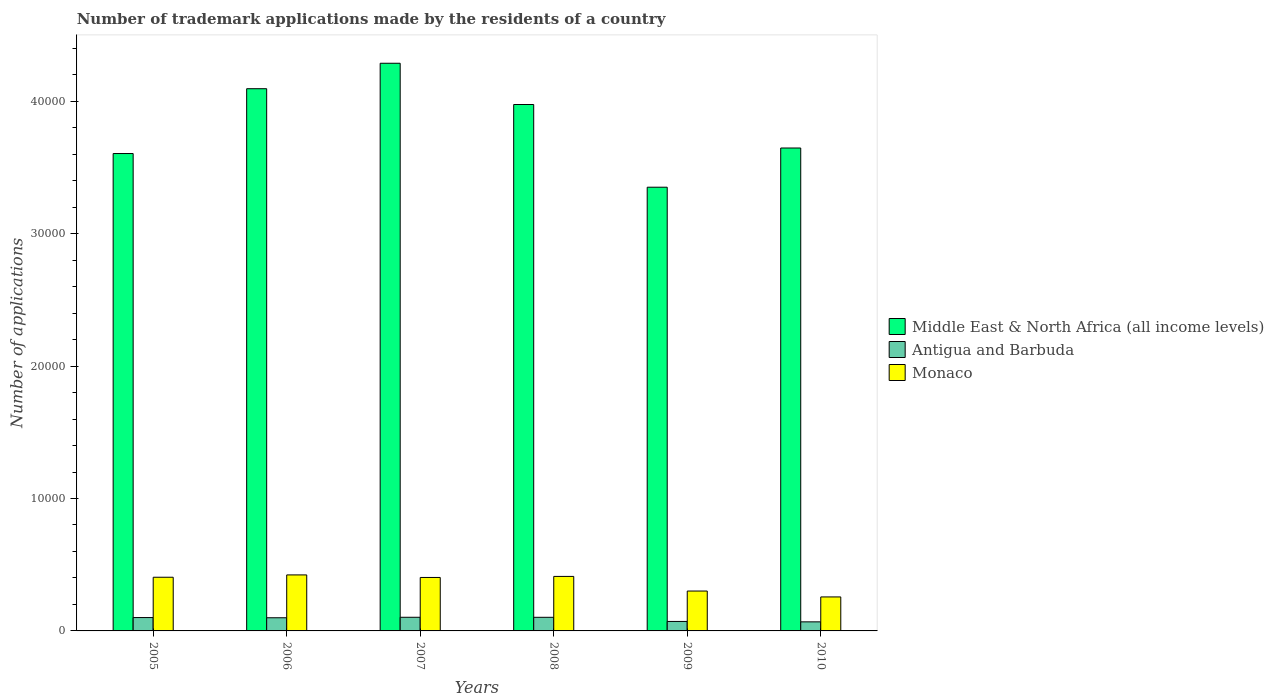Are the number of bars per tick equal to the number of legend labels?
Provide a succinct answer. Yes. How many bars are there on the 5th tick from the right?
Give a very brief answer. 3. What is the label of the 2nd group of bars from the left?
Offer a very short reply. 2006. In how many cases, is the number of bars for a given year not equal to the number of legend labels?
Your response must be concise. 0. What is the number of trademark applications made by the residents in Antigua and Barbuda in 2007?
Offer a very short reply. 1031. Across all years, what is the maximum number of trademark applications made by the residents in Monaco?
Give a very brief answer. 4229. Across all years, what is the minimum number of trademark applications made by the residents in Middle East & North Africa (all income levels)?
Provide a short and direct response. 3.35e+04. In which year was the number of trademark applications made by the residents in Middle East & North Africa (all income levels) minimum?
Your answer should be very brief. 2009. What is the total number of trademark applications made by the residents in Middle East & North Africa (all income levels) in the graph?
Your answer should be compact. 2.30e+05. What is the difference between the number of trademark applications made by the residents in Monaco in 2006 and that in 2007?
Offer a very short reply. 192. What is the difference between the number of trademark applications made by the residents in Antigua and Barbuda in 2009 and the number of trademark applications made by the residents in Middle East & North Africa (all income levels) in 2006?
Make the answer very short. -4.02e+04. What is the average number of trademark applications made by the residents in Middle East & North Africa (all income levels) per year?
Offer a very short reply. 3.83e+04. In the year 2005, what is the difference between the number of trademark applications made by the residents in Middle East & North Africa (all income levels) and number of trademark applications made by the residents in Monaco?
Your response must be concise. 3.20e+04. In how many years, is the number of trademark applications made by the residents in Antigua and Barbuda greater than 8000?
Make the answer very short. 0. What is the ratio of the number of trademark applications made by the residents in Monaco in 2005 to that in 2007?
Offer a very short reply. 1. Is the difference between the number of trademark applications made by the residents in Middle East & North Africa (all income levels) in 2008 and 2009 greater than the difference between the number of trademark applications made by the residents in Monaco in 2008 and 2009?
Ensure brevity in your answer.  Yes. What is the difference between the highest and the lowest number of trademark applications made by the residents in Antigua and Barbuda?
Your response must be concise. 346. In how many years, is the number of trademark applications made by the residents in Monaco greater than the average number of trademark applications made by the residents in Monaco taken over all years?
Provide a succinct answer. 4. Is the sum of the number of trademark applications made by the residents in Monaco in 2005 and 2009 greater than the maximum number of trademark applications made by the residents in Antigua and Barbuda across all years?
Ensure brevity in your answer.  Yes. What does the 3rd bar from the left in 2008 represents?
Your answer should be very brief. Monaco. What does the 3rd bar from the right in 2008 represents?
Make the answer very short. Middle East & North Africa (all income levels). Is it the case that in every year, the sum of the number of trademark applications made by the residents in Antigua and Barbuda and number of trademark applications made by the residents in Middle East & North Africa (all income levels) is greater than the number of trademark applications made by the residents in Monaco?
Offer a very short reply. Yes. How many bars are there?
Provide a succinct answer. 18. Are the values on the major ticks of Y-axis written in scientific E-notation?
Make the answer very short. No. Does the graph contain any zero values?
Keep it short and to the point. No. What is the title of the graph?
Make the answer very short. Number of trademark applications made by the residents of a country. What is the label or title of the X-axis?
Your response must be concise. Years. What is the label or title of the Y-axis?
Keep it short and to the point. Number of applications. What is the Number of applications of Middle East & North Africa (all income levels) in 2005?
Ensure brevity in your answer.  3.60e+04. What is the Number of applications in Antigua and Barbuda in 2005?
Make the answer very short. 1009. What is the Number of applications of Monaco in 2005?
Your response must be concise. 4053. What is the Number of applications of Middle East & North Africa (all income levels) in 2006?
Offer a very short reply. 4.09e+04. What is the Number of applications in Antigua and Barbuda in 2006?
Your answer should be very brief. 994. What is the Number of applications in Monaco in 2006?
Your answer should be very brief. 4229. What is the Number of applications in Middle East & North Africa (all income levels) in 2007?
Offer a terse response. 4.29e+04. What is the Number of applications in Antigua and Barbuda in 2007?
Keep it short and to the point. 1031. What is the Number of applications in Monaco in 2007?
Give a very brief answer. 4037. What is the Number of applications of Middle East & North Africa (all income levels) in 2008?
Provide a succinct answer. 3.98e+04. What is the Number of applications of Antigua and Barbuda in 2008?
Your answer should be compact. 1028. What is the Number of applications in Monaco in 2008?
Your response must be concise. 4116. What is the Number of applications in Middle East & North Africa (all income levels) in 2009?
Ensure brevity in your answer.  3.35e+04. What is the Number of applications of Antigua and Barbuda in 2009?
Provide a succinct answer. 716. What is the Number of applications in Monaco in 2009?
Your answer should be very brief. 3011. What is the Number of applications in Middle East & North Africa (all income levels) in 2010?
Provide a short and direct response. 3.65e+04. What is the Number of applications in Antigua and Barbuda in 2010?
Offer a very short reply. 685. What is the Number of applications in Monaco in 2010?
Your answer should be very brief. 2567. Across all years, what is the maximum Number of applications of Middle East & North Africa (all income levels)?
Your answer should be compact. 4.29e+04. Across all years, what is the maximum Number of applications of Antigua and Barbuda?
Your response must be concise. 1031. Across all years, what is the maximum Number of applications in Monaco?
Offer a terse response. 4229. Across all years, what is the minimum Number of applications of Middle East & North Africa (all income levels)?
Keep it short and to the point. 3.35e+04. Across all years, what is the minimum Number of applications in Antigua and Barbuda?
Your answer should be compact. 685. Across all years, what is the minimum Number of applications of Monaco?
Ensure brevity in your answer.  2567. What is the total Number of applications of Middle East & North Africa (all income levels) in the graph?
Provide a succinct answer. 2.30e+05. What is the total Number of applications of Antigua and Barbuda in the graph?
Provide a succinct answer. 5463. What is the total Number of applications of Monaco in the graph?
Keep it short and to the point. 2.20e+04. What is the difference between the Number of applications of Middle East & North Africa (all income levels) in 2005 and that in 2006?
Your answer should be very brief. -4895. What is the difference between the Number of applications of Monaco in 2005 and that in 2006?
Provide a succinct answer. -176. What is the difference between the Number of applications of Middle East & North Africa (all income levels) in 2005 and that in 2007?
Your answer should be very brief. -6817. What is the difference between the Number of applications of Antigua and Barbuda in 2005 and that in 2007?
Your answer should be compact. -22. What is the difference between the Number of applications of Middle East & North Africa (all income levels) in 2005 and that in 2008?
Offer a terse response. -3702. What is the difference between the Number of applications in Monaco in 2005 and that in 2008?
Provide a short and direct response. -63. What is the difference between the Number of applications in Middle East & North Africa (all income levels) in 2005 and that in 2009?
Your answer should be very brief. 2543. What is the difference between the Number of applications of Antigua and Barbuda in 2005 and that in 2009?
Keep it short and to the point. 293. What is the difference between the Number of applications of Monaco in 2005 and that in 2009?
Make the answer very short. 1042. What is the difference between the Number of applications in Middle East & North Africa (all income levels) in 2005 and that in 2010?
Keep it short and to the point. -417. What is the difference between the Number of applications of Antigua and Barbuda in 2005 and that in 2010?
Give a very brief answer. 324. What is the difference between the Number of applications of Monaco in 2005 and that in 2010?
Provide a succinct answer. 1486. What is the difference between the Number of applications of Middle East & North Africa (all income levels) in 2006 and that in 2007?
Provide a succinct answer. -1922. What is the difference between the Number of applications of Antigua and Barbuda in 2006 and that in 2007?
Keep it short and to the point. -37. What is the difference between the Number of applications in Monaco in 2006 and that in 2007?
Offer a terse response. 192. What is the difference between the Number of applications in Middle East & North Africa (all income levels) in 2006 and that in 2008?
Provide a succinct answer. 1193. What is the difference between the Number of applications of Antigua and Barbuda in 2006 and that in 2008?
Provide a succinct answer. -34. What is the difference between the Number of applications of Monaco in 2006 and that in 2008?
Your answer should be very brief. 113. What is the difference between the Number of applications of Middle East & North Africa (all income levels) in 2006 and that in 2009?
Provide a short and direct response. 7438. What is the difference between the Number of applications of Antigua and Barbuda in 2006 and that in 2009?
Your answer should be very brief. 278. What is the difference between the Number of applications in Monaco in 2006 and that in 2009?
Give a very brief answer. 1218. What is the difference between the Number of applications of Middle East & North Africa (all income levels) in 2006 and that in 2010?
Give a very brief answer. 4478. What is the difference between the Number of applications of Antigua and Barbuda in 2006 and that in 2010?
Offer a terse response. 309. What is the difference between the Number of applications of Monaco in 2006 and that in 2010?
Your response must be concise. 1662. What is the difference between the Number of applications of Middle East & North Africa (all income levels) in 2007 and that in 2008?
Keep it short and to the point. 3115. What is the difference between the Number of applications of Monaco in 2007 and that in 2008?
Your answer should be compact. -79. What is the difference between the Number of applications in Middle East & North Africa (all income levels) in 2007 and that in 2009?
Make the answer very short. 9360. What is the difference between the Number of applications of Antigua and Barbuda in 2007 and that in 2009?
Provide a succinct answer. 315. What is the difference between the Number of applications in Monaco in 2007 and that in 2009?
Offer a terse response. 1026. What is the difference between the Number of applications of Middle East & North Africa (all income levels) in 2007 and that in 2010?
Your response must be concise. 6400. What is the difference between the Number of applications in Antigua and Barbuda in 2007 and that in 2010?
Ensure brevity in your answer.  346. What is the difference between the Number of applications of Monaco in 2007 and that in 2010?
Provide a short and direct response. 1470. What is the difference between the Number of applications in Middle East & North Africa (all income levels) in 2008 and that in 2009?
Ensure brevity in your answer.  6245. What is the difference between the Number of applications in Antigua and Barbuda in 2008 and that in 2009?
Make the answer very short. 312. What is the difference between the Number of applications of Monaco in 2008 and that in 2009?
Ensure brevity in your answer.  1105. What is the difference between the Number of applications of Middle East & North Africa (all income levels) in 2008 and that in 2010?
Give a very brief answer. 3285. What is the difference between the Number of applications of Antigua and Barbuda in 2008 and that in 2010?
Offer a very short reply. 343. What is the difference between the Number of applications in Monaco in 2008 and that in 2010?
Keep it short and to the point. 1549. What is the difference between the Number of applications in Middle East & North Africa (all income levels) in 2009 and that in 2010?
Make the answer very short. -2960. What is the difference between the Number of applications in Antigua and Barbuda in 2009 and that in 2010?
Offer a very short reply. 31. What is the difference between the Number of applications of Monaco in 2009 and that in 2010?
Offer a very short reply. 444. What is the difference between the Number of applications of Middle East & North Africa (all income levels) in 2005 and the Number of applications of Antigua and Barbuda in 2006?
Provide a succinct answer. 3.51e+04. What is the difference between the Number of applications of Middle East & North Africa (all income levels) in 2005 and the Number of applications of Monaco in 2006?
Provide a succinct answer. 3.18e+04. What is the difference between the Number of applications in Antigua and Barbuda in 2005 and the Number of applications in Monaco in 2006?
Provide a succinct answer. -3220. What is the difference between the Number of applications in Middle East & North Africa (all income levels) in 2005 and the Number of applications in Antigua and Barbuda in 2007?
Provide a short and direct response. 3.50e+04. What is the difference between the Number of applications of Middle East & North Africa (all income levels) in 2005 and the Number of applications of Monaco in 2007?
Offer a terse response. 3.20e+04. What is the difference between the Number of applications of Antigua and Barbuda in 2005 and the Number of applications of Monaco in 2007?
Provide a succinct answer. -3028. What is the difference between the Number of applications of Middle East & North Africa (all income levels) in 2005 and the Number of applications of Antigua and Barbuda in 2008?
Provide a short and direct response. 3.50e+04. What is the difference between the Number of applications of Middle East & North Africa (all income levels) in 2005 and the Number of applications of Monaco in 2008?
Provide a succinct answer. 3.19e+04. What is the difference between the Number of applications in Antigua and Barbuda in 2005 and the Number of applications in Monaco in 2008?
Make the answer very short. -3107. What is the difference between the Number of applications of Middle East & North Africa (all income levels) in 2005 and the Number of applications of Antigua and Barbuda in 2009?
Offer a very short reply. 3.53e+04. What is the difference between the Number of applications of Middle East & North Africa (all income levels) in 2005 and the Number of applications of Monaco in 2009?
Provide a succinct answer. 3.30e+04. What is the difference between the Number of applications of Antigua and Barbuda in 2005 and the Number of applications of Monaco in 2009?
Your response must be concise. -2002. What is the difference between the Number of applications in Middle East & North Africa (all income levels) in 2005 and the Number of applications in Antigua and Barbuda in 2010?
Make the answer very short. 3.54e+04. What is the difference between the Number of applications in Middle East & North Africa (all income levels) in 2005 and the Number of applications in Monaco in 2010?
Provide a succinct answer. 3.35e+04. What is the difference between the Number of applications of Antigua and Barbuda in 2005 and the Number of applications of Monaco in 2010?
Your answer should be very brief. -1558. What is the difference between the Number of applications of Middle East & North Africa (all income levels) in 2006 and the Number of applications of Antigua and Barbuda in 2007?
Your response must be concise. 3.99e+04. What is the difference between the Number of applications of Middle East & North Africa (all income levels) in 2006 and the Number of applications of Monaco in 2007?
Give a very brief answer. 3.69e+04. What is the difference between the Number of applications in Antigua and Barbuda in 2006 and the Number of applications in Monaco in 2007?
Ensure brevity in your answer.  -3043. What is the difference between the Number of applications in Middle East & North Africa (all income levels) in 2006 and the Number of applications in Antigua and Barbuda in 2008?
Your response must be concise. 3.99e+04. What is the difference between the Number of applications in Middle East & North Africa (all income levels) in 2006 and the Number of applications in Monaco in 2008?
Provide a short and direct response. 3.68e+04. What is the difference between the Number of applications in Antigua and Barbuda in 2006 and the Number of applications in Monaco in 2008?
Provide a succinct answer. -3122. What is the difference between the Number of applications in Middle East & North Africa (all income levels) in 2006 and the Number of applications in Antigua and Barbuda in 2009?
Offer a very short reply. 4.02e+04. What is the difference between the Number of applications in Middle East & North Africa (all income levels) in 2006 and the Number of applications in Monaco in 2009?
Keep it short and to the point. 3.79e+04. What is the difference between the Number of applications of Antigua and Barbuda in 2006 and the Number of applications of Monaco in 2009?
Your answer should be very brief. -2017. What is the difference between the Number of applications in Middle East & North Africa (all income levels) in 2006 and the Number of applications in Antigua and Barbuda in 2010?
Give a very brief answer. 4.03e+04. What is the difference between the Number of applications of Middle East & North Africa (all income levels) in 2006 and the Number of applications of Monaco in 2010?
Offer a terse response. 3.84e+04. What is the difference between the Number of applications in Antigua and Barbuda in 2006 and the Number of applications in Monaco in 2010?
Provide a short and direct response. -1573. What is the difference between the Number of applications of Middle East & North Africa (all income levels) in 2007 and the Number of applications of Antigua and Barbuda in 2008?
Your response must be concise. 4.18e+04. What is the difference between the Number of applications of Middle East & North Africa (all income levels) in 2007 and the Number of applications of Monaco in 2008?
Offer a very short reply. 3.87e+04. What is the difference between the Number of applications of Antigua and Barbuda in 2007 and the Number of applications of Monaco in 2008?
Keep it short and to the point. -3085. What is the difference between the Number of applications of Middle East & North Africa (all income levels) in 2007 and the Number of applications of Antigua and Barbuda in 2009?
Offer a terse response. 4.21e+04. What is the difference between the Number of applications in Middle East & North Africa (all income levels) in 2007 and the Number of applications in Monaco in 2009?
Keep it short and to the point. 3.99e+04. What is the difference between the Number of applications in Antigua and Barbuda in 2007 and the Number of applications in Monaco in 2009?
Offer a terse response. -1980. What is the difference between the Number of applications of Middle East & North Africa (all income levels) in 2007 and the Number of applications of Antigua and Barbuda in 2010?
Offer a very short reply. 4.22e+04. What is the difference between the Number of applications of Middle East & North Africa (all income levels) in 2007 and the Number of applications of Monaco in 2010?
Keep it short and to the point. 4.03e+04. What is the difference between the Number of applications of Antigua and Barbuda in 2007 and the Number of applications of Monaco in 2010?
Ensure brevity in your answer.  -1536. What is the difference between the Number of applications of Middle East & North Africa (all income levels) in 2008 and the Number of applications of Antigua and Barbuda in 2009?
Offer a terse response. 3.90e+04. What is the difference between the Number of applications in Middle East & North Africa (all income levels) in 2008 and the Number of applications in Monaco in 2009?
Keep it short and to the point. 3.67e+04. What is the difference between the Number of applications in Antigua and Barbuda in 2008 and the Number of applications in Monaco in 2009?
Your answer should be very brief. -1983. What is the difference between the Number of applications in Middle East & North Africa (all income levels) in 2008 and the Number of applications in Antigua and Barbuda in 2010?
Provide a succinct answer. 3.91e+04. What is the difference between the Number of applications in Middle East & North Africa (all income levels) in 2008 and the Number of applications in Monaco in 2010?
Give a very brief answer. 3.72e+04. What is the difference between the Number of applications in Antigua and Barbuda in 2008 and the Number of applications in Monaco in 2010?
Provide a short and direct response. -1539. What is the difference between the Number of applications in Middle East & North Africa (all income levels) in 2009 and the Number of applications in Antigua and Barbuda in 2010?
Make the answer very short. 3.28e+04. What is the difference between the Number of applications in Middle East & North Africa (all income levels) in 2009 and the Number of applications in Monaco in 2010?
Give a very brief answer. 3.09e+04. What is the difference between the Number of applications of Antigua and Barbuda in 2009 and the Number of applications of Monaco in 2010?
Your answer should be very brief. -1851. What is the average Number of applications of Middle East & North Africa (all income levels) per year?
Provide a succinct answer. 3.83e+04. What is the average Number of applications of Antigua and Barbuda per year?
Offer a very short reply. 910.5. What is the average Number of applications of Monaco per year?
Provide a short and direct response. 3668.83. In the year 2005, what is the difference between the Number of applications in Middle East & North Africa (all income levels) and Number of applications in Antigua and Barbuda?
Keep it short and to the point. 3.50e+04. In the year 2005, what is the difference between the Number of applications of Middle East & North Africa (all income levels) and Number of applications of Monaco?
Keep it short and to the point. 3.20e+04. In the year 2005, what is the difference between the Number of applications in Antigua and Barbuda and Number of applications in Monaco?
Provide a succinct answer. -3044. In the year 2006, what is the difference between the Number of applications of Middle East & North Africa (all income levels) and Number of applications of Antigua and Barbuda?
Your answer should be very brief. 3.99e+04. In the year 2006, what is the difference between the Number of applications in Middle East & North Africa (all income levels) and Number of applications in Monaco?
Keep it short and to the point. 3.67e+04. In the year 2006, what is the difference between the Number of applications in Antigua and Barbuda and Number of applications in Monaco?
Ensure brevity in your answer.  -3235. In the year 2007, what is the difference between the Number of applications of Middle East & North Africa (all income levels) and Number of applications of Antigua and Barbuda?
Keep it short and to the point. 4.18e+04. In the year 2007, what is the difference between the Number of applications in Middle East & North Africa (all income levels) and Number of applications in Monaco?
Your answer should be very brief. 3.88e+04. In the year 2007, what is the difference between the Number of applications in Antigua and Barbuda and Number of applications in Monaco?
Your answer should be very brief. -3006. In the year 2008, what is the difference between the Number of applications in Middle East & North Africa (all income levels) and Number of applications in Antigua and Barbuda?
Your answer should be compact. 3.87e+04. In the year 2008, what is the difference between the Number of applications of Middle East & North Africa (all income levels) and Number of applications of Monaco?
Your answer should be very brief. 3.56e+04. In the year 2008, what is the difference between the Number of applications in Antigua and Barbuda and Number of applications in Monaco?
Offer a very short reply. -3088. In the year 2009, what is the difference between the Number of applications of Middle East & North Africa (all income levels) and Number of applications of Antigua and Barbuda?
Offer a very short reply. 3.28e+04. In the year 2009, what is the difference between the Number of applications in Middle East & North Africa (all income levels) and Number of applications in Monaco?
Offer a terse response. 3.05e+04. In the year 2009, what is the difference between the Number of applications of Antigua and Barbuda and Number of applications of Monaco?
Make the answer very short. -2295. In the year 2010, what is the difference between the Number of applications in Middle East & North Africa (all income levels) and Number of applications in Antigua and Barbuda?
Offer a terse response. 3.58e+04. In the year 2010, what is the difference between the Number of applications of Middle East & North Africa (all income levels) and Number of applications of Monaco?
Your response must be concise. 3.39e+04. In the year 2010, what is the difference between the Number of applications of Antigua and Barbuda and Number of applications of Monaco?
Your answer should be very brief. -1882. What is the ratio of the Number of applications in Middle East & North Africa (all income levels) in 2005 to that in 2006?
Ensure brevity in your answer.  0.88. What is the ratio of the Number of applications of Antigua and Barbuda in 2005 to that in 2006?
Provide a short and direct response. 1.02. What is the ratio of the Number of applications of Monaco in 2005 to that in 2006?
Ensure brevity in your answer.  0.96. What is the ratio of the Number of applications in Middle East & North Africa (all income levels) in 2005 to that in 2007?
Your answer should be compact. 0.84. What is the ratio of the Number of applications of Antigua and Barbuda in 2005 to that in 2007?
Give a very brief answer. 0.98. What is the ratio of the Number of applications of Middle East & North Africa (all income levels) in 2005 to that in 2008?
Provide a succinct answer. 0.91. What is the ratio of the Number of applications in Antigua and Barbuda in 2005 to that in 2008?
Your response must be concise. 0.98. What is the ratio of the Number of applications of Monaco in 2005 to that in 2008?
Offer a very short reply. 0.98. What is the ratio of the Number of applications in Middle East & North Africa (all income levels) in 2005 to that in 2009?
Your answer should be very brief. 1.08. What is the ratio of the Number of applications of Antigua and Barbuda in 2005 to that in 2009?
Offer a very short reply. 1.41. What is the ratio of the Number of applications of Monaco in 2005 to that in 2009?
Your answer should be very brief. 1.35. What is the ratio of the Number of applications of Middle East & North Africa (all income levels) in 2005 to that in 2010?
Offer a terse response. 0.99. What is the ratio of the Number of applications in Antigua and Barbuda in 2005 to that in 2010?
Your response must be concise. 1.47. What is the ratio of the Number of applications of Monaco in 2005 to that in 2010?
Give a very brief answer. 1.58. What is the ratio of the Number of applications in Middle East & North Africa (all income levels) in 2006 to that in 2007?
Make the answer very short. 0.96. What is the ratio of the Number of applications in Antigua and Barbuda in 2006 to that in 2007?
Keep it short and to the point. 0.96. What is the ratio of the Number of applications in Monaco in 2006 to that in 2007?
Your answer should be very brief. 1.05. What is the ratio of the Number of applications in Middle East & North Africa (all income levels) in 2006 to that in 2008?
Offer a terse response. 1.03. What is the ratio of the Number of applications of Antigua and Barbuda in 2006 to that in 2008?
Give a very brief answer. 0.97. What is the ratio of the Number of applications in Monaco in 2006 to that in 2008?
Give a very brief answer. 1.03. What is the ratio of the Number of applications of Middle East & North Africa (all income levels) in 2006 to that in 2009?
Your response must be concise. 1.22. What is the ratio of the Number of applications of Antigua and Barbuda in 2006 to that in 2009?
Offer a terse response. 1.39. What is the ratio of the Number of applications of Monaco in 2006 to that in 2009?
Offer a terse response. 1.4. What is the ratio of the Number of applications of Middle East & North Africa (all income levels) in 2006 to that in 2010?
Give a very brief answer. 1.12. What is the ratio of the Number of applications in Antigua and Barbuda in 2006 to that in 2010?
Make the answer very short. 1.45. What is the ratio of the Number of applications of Monaco in 2006 to that in 2010?
Give a very brief answer. 1.65. What is the ratio of the Number of applications in Middle East & North Africa (all income levels) in 2007 to that in 2008?
Keep it short and to the point. 1.08. What is the ratio of the Number of applications of Antigua and Barbuda in 2007 to that in 2008?
Provide a short and direct response. 1. What is the ratio of the Number of applications of Monaco in 2007 to that in 2008?
Provide a short and direct response. 0.98. What is the ratio of the Number of applications in Middle East & North Africa (all income levels) in 2007 to that in 2009?
Your answer should be compact. 1.28. What is the ratio of the Number of applications in Antigua and Barbuda in 2007 to that in 2009?
Offer a very short reply. 1.44. What is the ratio of the Number of applications of Monaco in 2007 to that in 2009?
Keep it short and to the point. 1.34. What is the ratio of the Number of applications of Middle East & North Africa (all income levels) in 2007 to that in 2010?
Your answer should be compact. 1.18. What is the ratio of the Number of applications of Antigua and Barbuda in 2007 to that in 2010?
Give a very brief answer. 1.51. What is the ratio of the Number of applications of Monaco in 2007 to that in 2010?
Make the answer very short. 1.57. What is the ratio of the Number of applications of Middle East & North Africa (all income levels) in 2008 to that in 2009?
Provide a short and direct response. 1.19. What is the ratio of the Number of applications of Antigua and Barbuda in 2008 to that in 2009?
Offer a terse response. 1.44. What is the ratio of the Number of applications of Monaco in 2008 to that in 2009?
Your answer should be very brief. 1.37. What is the ratio of the Number of applications in Middle East & North Africa (all income levels) in 2008 to that in 2010?
Make the answer very short. 1.09. What is the ratio of the Number of applications in Antigua and Barbuda in 2008 to that in 2010?
Your answer should be very brief. 1.5. What is the ratio of the Number of applications of Monaco in 2008 to that in 2010?
Your response must be concise. 1.6. What is the ratio of the Number of applications in Middle East & North Africa (all income levels) in 2009 to that in 2010?
Provide a succinct answer. 0.92. What is the ratio of the Number of applications in Antigua and Barbuda in 2009 to that in 2010?
Provide a succinct answer. 1.05. What is the ratio of the Number of applications in Monaco in 2009 to that in 2010?
Provide a short and direct response. 1.17. What is the difference between the highest and the second highest Number of applications in Middle East & North Africa (all income levels)?
Provide a succinct answer. 1922. What is the difference between the highest and the second highest Number of applications in Antigua and Barbuda?
Provide a short and direct response. 3. What is the difference between the highest and the second highest Number of applications in Monaco?
Your response must be concise. 113. What is the difference between the highest and the lowest Number of applications of Middle East & North Africa (all income levels)?
Offer a terse response. 9360. What is the difference between the highest and the lowest Number of applications of Antigua and Barbuda?
Provide a short and direct response. 346. What is the difference between the highest and the lowest Number of applications in Monaco?
Give a very brief answer. 1662. 